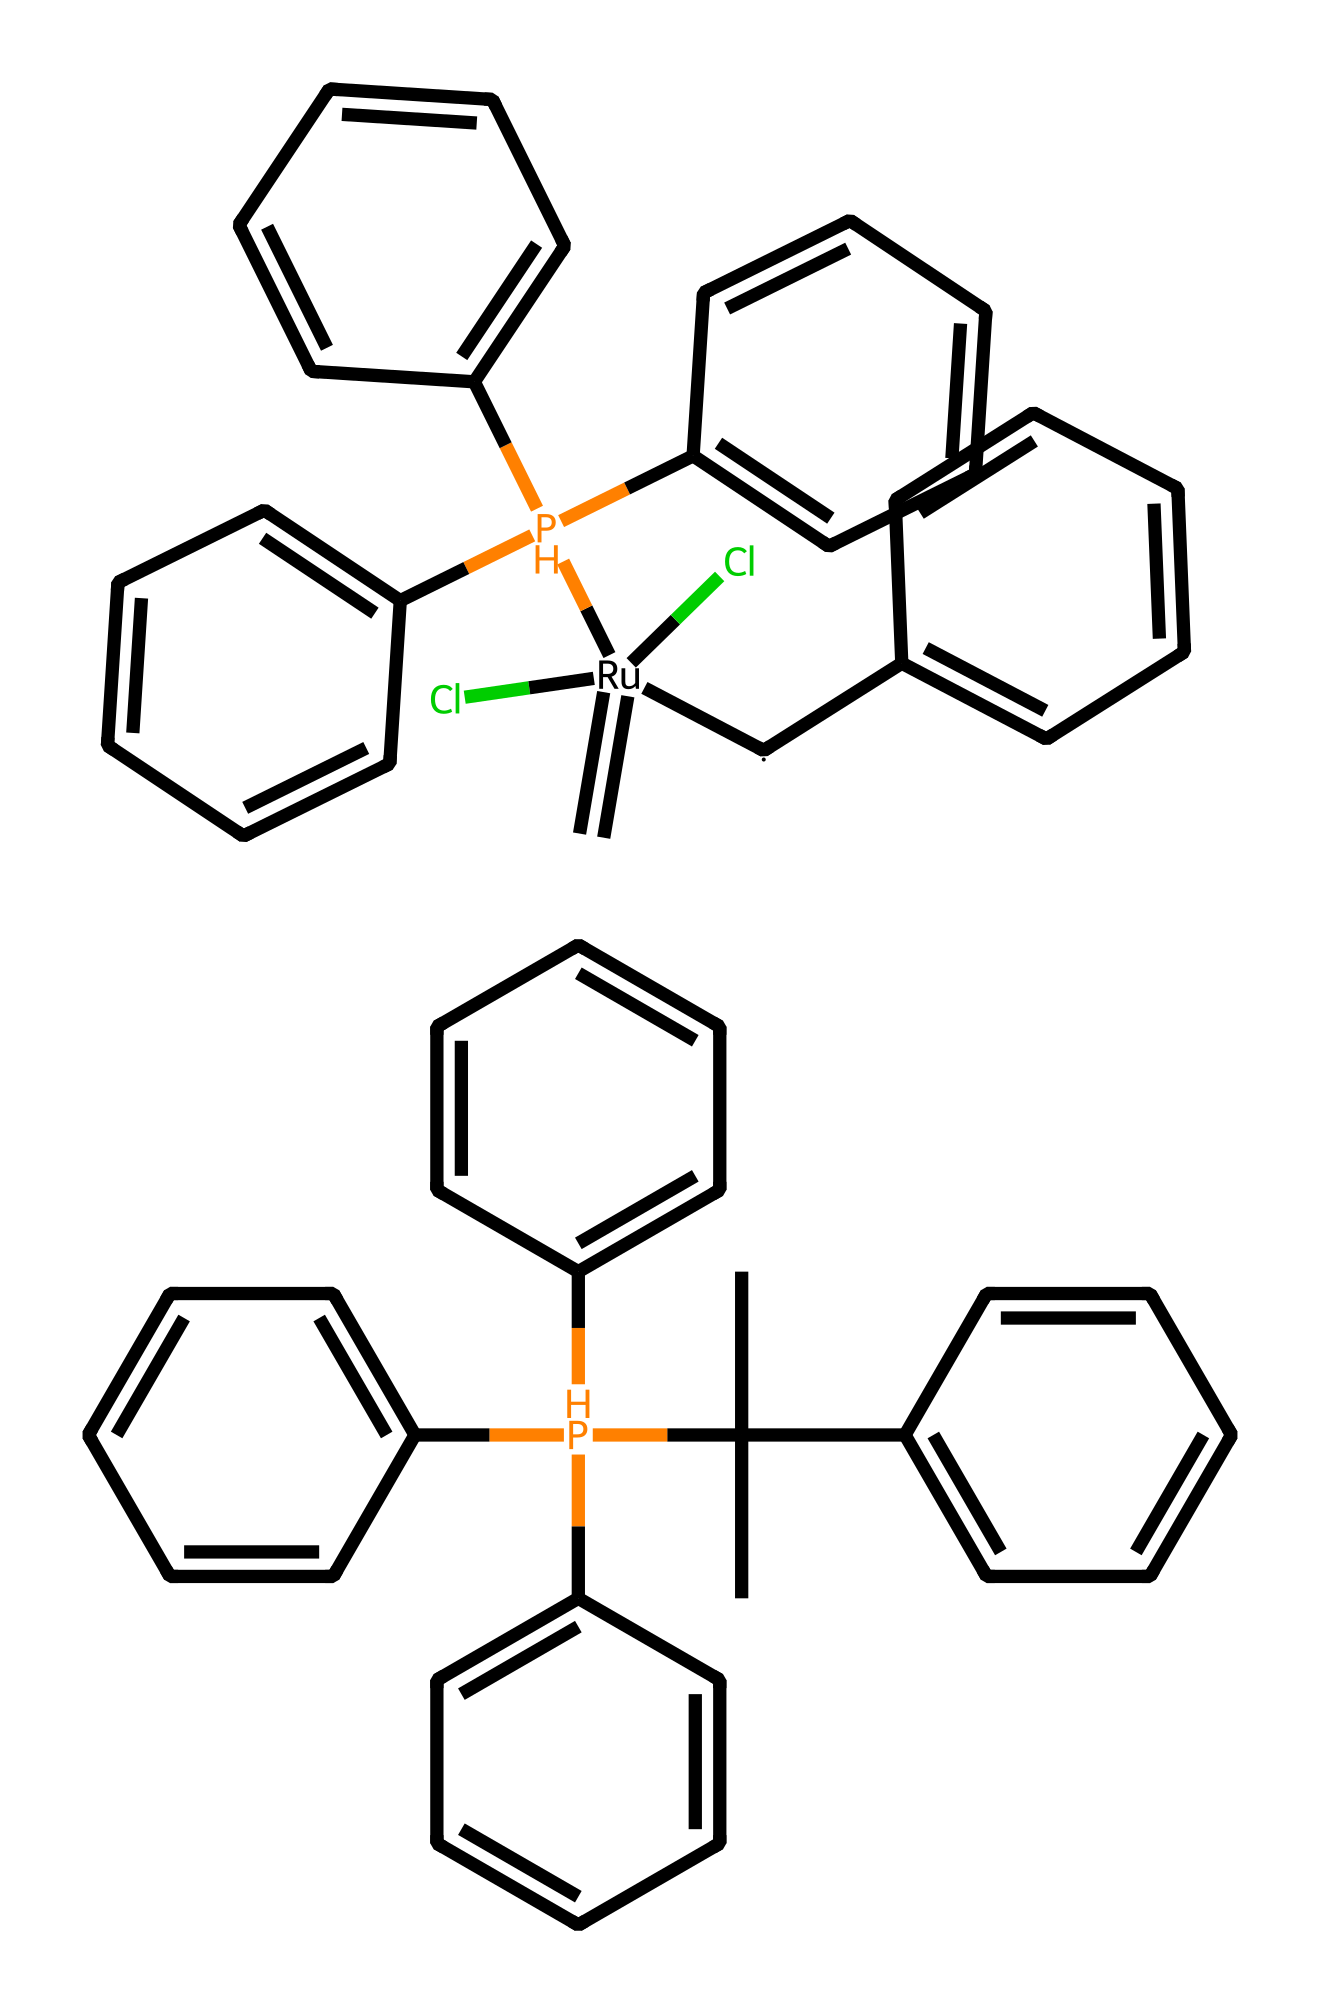What is the metal center in this compound? The structure depicts a ruthenium atom (Ru) experiencing coordination with other ligands. The central atom is crucial for its organometallic properties.
Answer: ruthenium How many carbon atoms are present in the compound? By analyzing the structure, we find numerous carbon rings and branches, totaling 30 carbon atoms throughout the entire compound.
Answer: 30 What type of reaction does the Grubbs catalyst facilitate? The Grubbs catalyst is specifically designed to promote olefin metathesis reactions, which involve the exchange of alkylene groups between olefins.
Answer: olefin metathesis What are the ligands coordinating with the metal center? The structure shows multiple phosphine and chlorido groups coordinated to the ruthenium center, specifically three phosphine ligands and two chloride ligands.
Answer: phosphine and chloride What is the overall charge of the complex? The presence of neutral ligands and overall arrangement indicates a neutral complex; thus, the compound has an overall charge of zero.
Answer: zero How many rings are formed in this compound? By examining the structure closely, it becomes apparent there are six aromatic rings within the molecular architecture.
Answer: six 